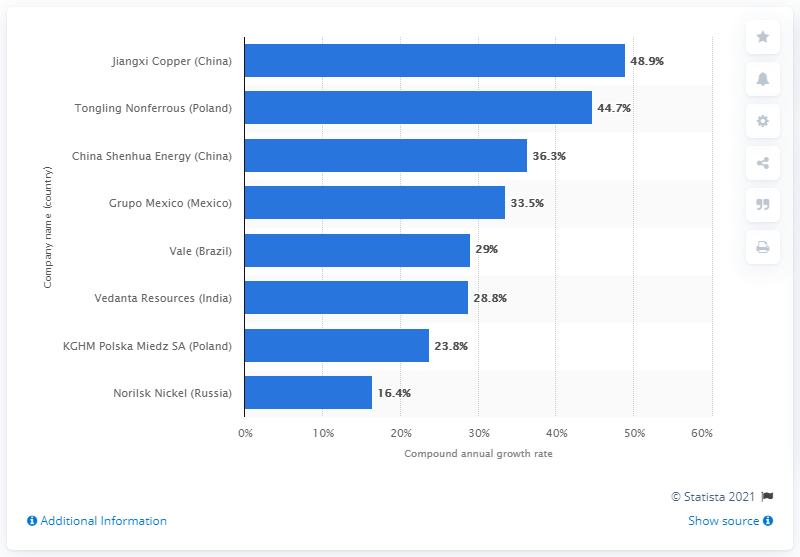List a handful of essential elements in this visual. The compound annual growth rate of Vale was 29% from 2015 to 2020. 